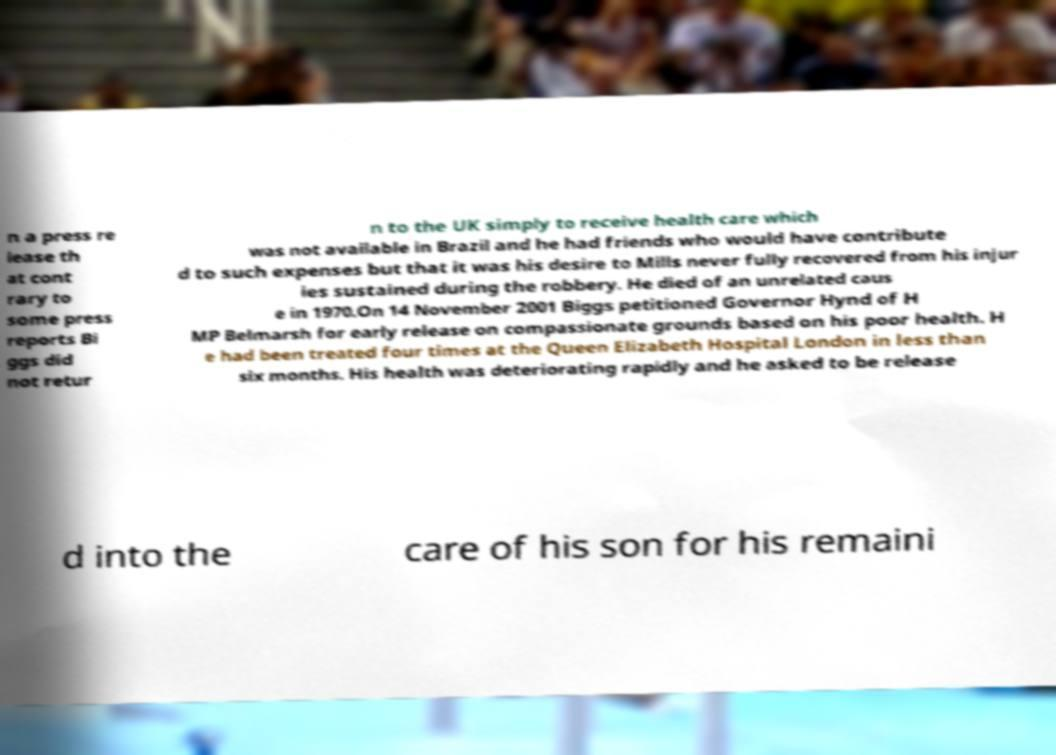Can you accurately transcribe the text from the provided image for me? n a press re lease th at cont rary to some press reports Bi ggs did not retur n to the UK simply to receive health care which was not available in Brazil and he had friends who would have contribute d to such expenses but that it was his desire to Mills never fully recovered from his injur ies sustained during the robbery. He died of an unrelated caus e in 1970.On 14 November 2001 Biggs petitioned Governor Hynd of H MP Belmarsh for early release on compassionate grounds based on his poor health. H e had been treated four times at the Queen Elizabeth Hospital London in less than six months. His health was deteriorating rapidly and he asked to be release d into the care of his son for his remaini 